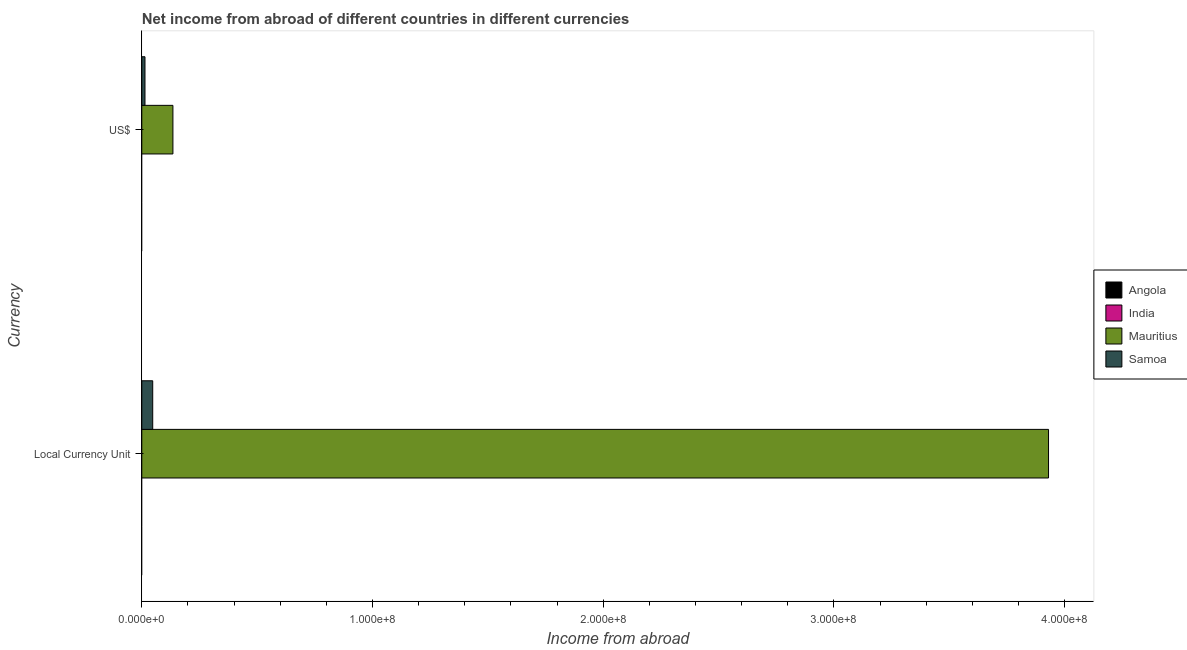How many different coloured bars are there?
Offer a very short reply. 2. How many groups of bars are there?
Offer a very short reply. 2. Are the number of bars per tick equal to the number of legend labels?
Give a very brief answer. No. How many bars are there on the 1st tick from the bottom?
Provide a short and direct response. 2. What is the label of the 2nd group of bars from the top?
Your answer should be compact. Local Currency Unit. What is the income from abroad in us$ in Mauritius?
Offer a terse response. 1.35e+07. Across all countries, what is the maximum income from abroad in constant 2005 us$?
Ensure brevity in your answer.  3.93e+08. In which country was the income from abroad in constant 2005 us$ maximum?
Offer a very short reply. Mauritius. What is the total income from abroad in us$ in the graph?
Give a very brief answer. 1.49e+07. What is the difference between the income from abroad in constant 2005 us$ in Samoa and that in Mauritius?
Make the answer very short. -3.88e+08. What is the difference between the income from abroad in constant 2005 us$ in Angola and the income from abroad in us$ in Samoa?
Your answer should be compact. -1.38e+06. What is the average income from abroad in constant 2005 us$ per country?
Your answer should be compact. 9.94e+07. What is the difference between the income from abroad in us$ and income from abroad in constant 2005 us$ in Samoa?
Keep it short and to the point. -3.35e+06. How many countries are there in the graph?
Your response must be concise. 4. What is the difference between two consecutive major ticks on the X-axis?
Give a very brief answer. 1.00e+08. Are the values on the major ticks of X-axis written in scientific E-notation?
Offer a very short reply. Yes. Where does the legend appear in the graph?
Offer a very short reply. Center right. What is the title of the graph?
Provide a succinct answer. Net income from abroad of different countries in different currencies. Does "Lebanon" appear as one of the legend labels in the graph?
Make the answer very short. No. What is the label or title of the X-axis?
Your response must be concise. Income from abroad. What is the label or title of the Y-axis?
Provide a succinct answer. Currency. What is the Income from abroad in Angola in Local Currency Unit?
Ensure brevity in your answer.  0. What is the Income from abroad of India in Local Currency Unit?
Provide a short and direct response. 0. What is the Income from abroad in Mauritius in Local Currency Unit?
Provide a succinct answer. 3.93e+08. What is the Income from abroad in Samoa in Local Currency Unit?
Give a very brief answer. 4.73e+06. What is the Income from abroad in Angola in US$?
Offer a very short reply. 0. What is the Income from abroad of India in US$?
Ensure brevity in your answer.  0. What is the Income from abroad in Mauritius in US$?
Provide a short and direct response. 1.35e+07. What is the Income from abroad in Samoa in US$?
Offer a terse response. 1.38e+06. Across all Currency, what is the maximum Income from abroad of Mauritius?
Make the answer very short. 3.93e+08. Across all Currency, what is the maximum Income from abroad in Samoa?
Give a very brief answer. 4.73e+06. Across all Currency, what is the minimum Income from abroad of Mauritius?
Your response must be concise. 1.35e+07. Across all Currency, what is the minimum Income from abroad of Samoa?
Provide a succinct answer. 1.38e+06. What is the total Income from abroad in Angola in the graph?
Make the answer very short. 0. What is the total Income from abroad in India in the graph?
Provide a short and direct response. 0. What is the total Income from abroad in Mauritius in the graph?
Your answer should be very brief. 4.06e+08. What is the total Income from abroad of Samoa in the graph?
Ensure brevity in your answer.  6.11e+06. What is the difference between the Income from abroad of Mauritius in Local Currency Unit and that in US$?
Provide a succinct answer. 3.80e+08. What is the difference between the Income from abroad of Samoa in Local Currency Unit and that in US$?
Your response must be concise. 3.35e+06. What is the difference between the Income from abroad in Mauritius in Local Currency Unit and the Income from abroad in Samoa in US$?
Your answer should be very brief. 3.92e+08. What is the average Income from abroad of Angola per Currency?
Your answer should be very brief. 0. What is the average Income from abroad in Mauritius per Currency?
Make the answer very short. 2.03e+08. What is the average Income from abroad of Samoa per Currency?
Your answer should be very brief. 3.06e+06. What is the difference between the Income from abroad of Mauritius and Income from abroad of Samoa in Local Currency Unit?
Your answer should be compact. 3.88e+08. What is the difference between the Income from abroad of Mauritius and Income from abroad of Samoa in US$?
Offer a very short reply. 1.21e+07. What is the ratio of the Income from abroad in Mauritius in Local Currency Unit to that in US$?
Provide a succinct answer. 29.13. What is the ratio of the Income from abroad in Samoa in Local Currency Unit to that in US$?
Your response must be concise. 3.43. What is the difference between the highest and the second highest Income from abroad in Mauritius?
Your answer should be very brief. 3.80e+08. What is the difference between the highest and the second highest Income from abroad of Samoa?
Provide a succinct answer. 3.35e+06. What is the difference between the highest and the lowest Income from abroad of Mauritius?
Ensure brevity in your answer.  3.80e+08. What is the difference between the highest and the lowest Income from abroad of Samoa?
Provide a succinct answer. 3.35e+06. 